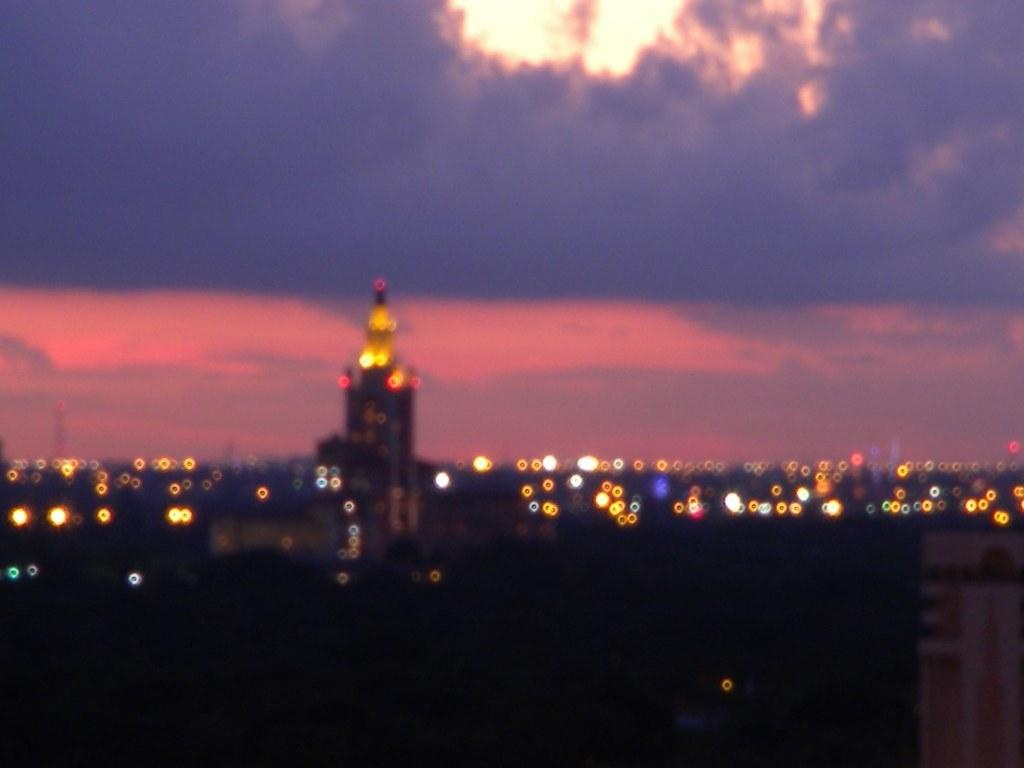What type of structure is visible in the image? There is a building in the image. Can you describe the lighting in the image? There are many lights in the image. How would you describe the quality of the image? The image is blurry. What is visible at the top of the image? Sky is visible at the top of the image. What can be observed in the sky? Clouds are present in the sky. What type of pear is being used to gain approval from society in the image? There is no pear or reference to approval or society present in the image. 